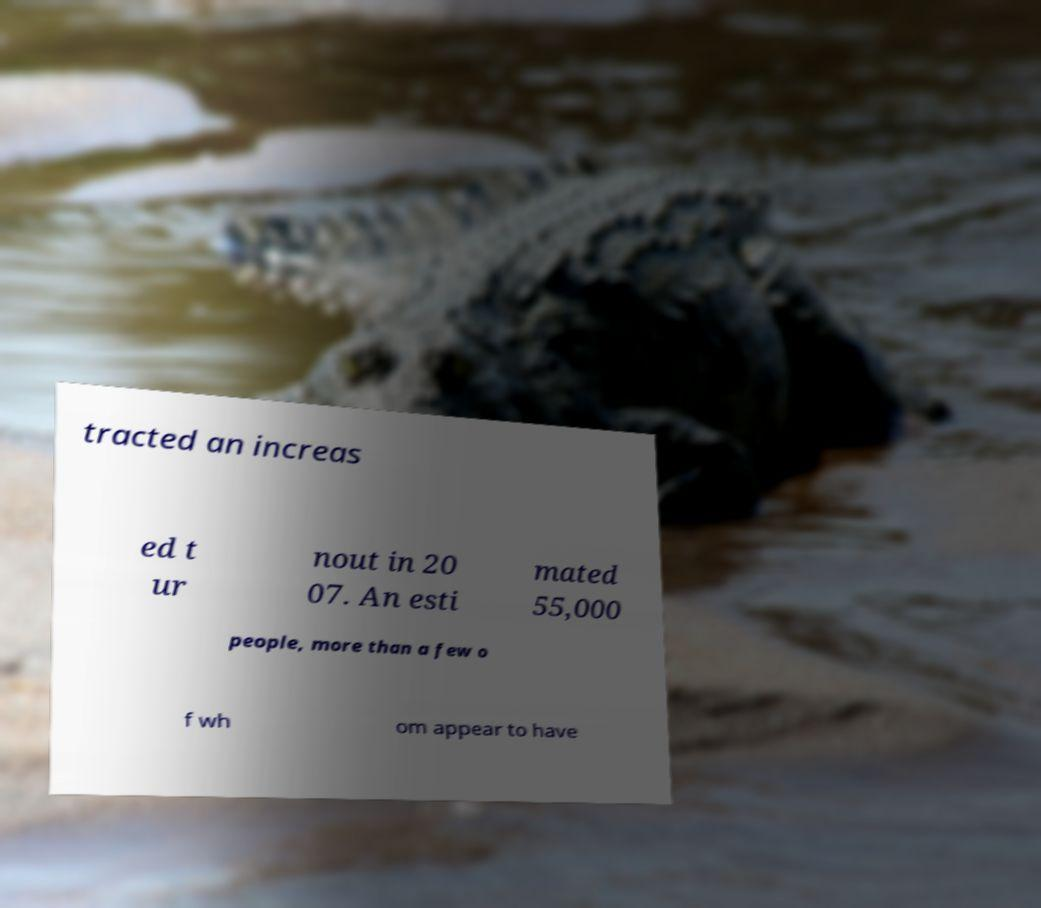I need the written content from this picture converted into text. Can you do that? tracted an increas ed t ur nout in 20 07. An esti mated 55,000 people, more than a few o f wh om appear to have 